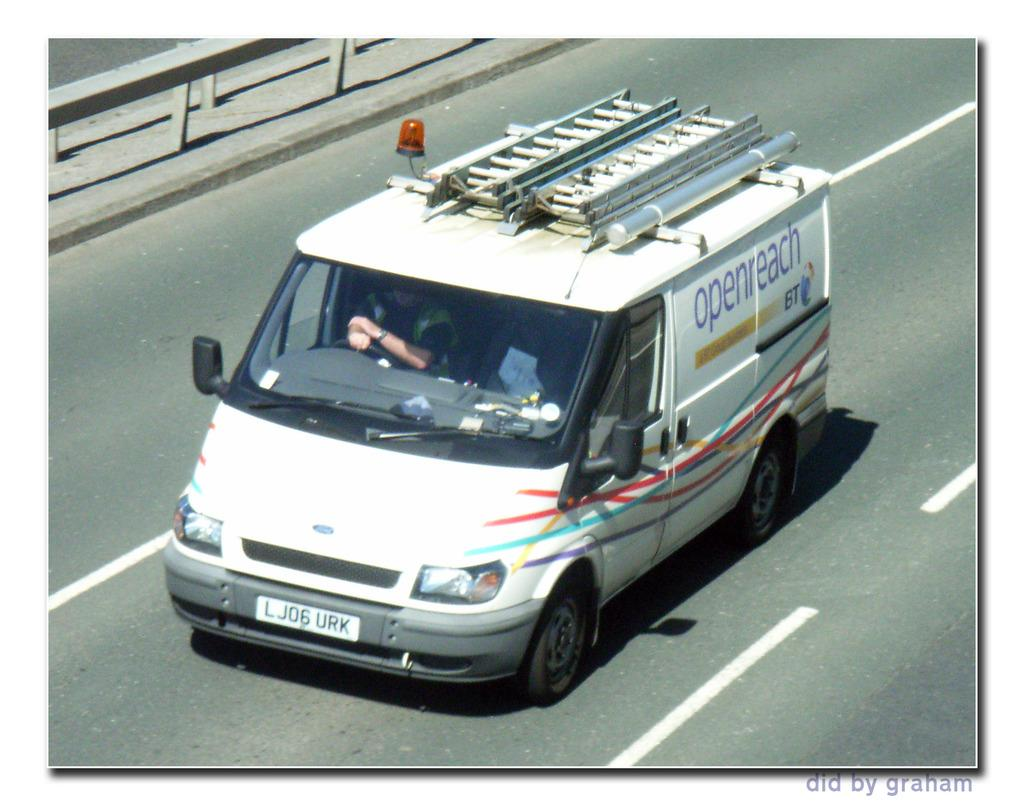What is the main subject of the image? There is a vehicle in the image. Where is the vehicle located? The vehicle is on the road. Can you describe the person inside the vehicle? There is a person inside the vehicle, and they are sitting in front of the steering wheel. What type of milk is being poured into the bath in the image? There is no milk or bath present in the image; it features a vehicle on the road with a person sitting in front of the steering wheel. 